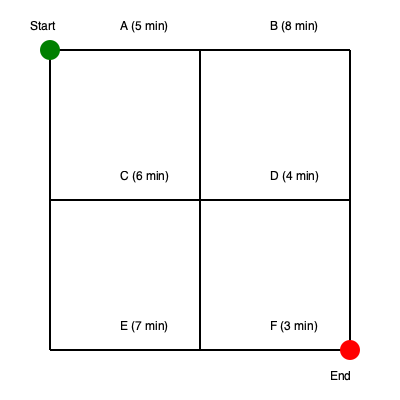As a firefighter coordinating an evacuation, you need to determine the fastest route from the start point (green) to the end point (red) through this grid-like road network. Each segment is labeled with its travel time in minutes. What is the minimum time required to reach the end point? To find the fastest route, we need to consider all possible paths and calculate their total times:

1. Start → A → B → D → F → End
   Time: $5 + 8 + 4 + 3 = 20$ minutes

2. Start → A → C → D → F → End
   Time: $5 + 6 + 4 + 3 = 18$ minutes

3. Start → A → C → E → F → End
   Time: $5 + 6 + 7 + 3 = 21$ minutes

4. Start → C → D → F → End
   Time: $6 + 4 + 3 = 13$ minutes

5. Start → C → E → F → End
   Time: $6 + 7 + 3 = 16$ minutes

The fastest route is option 4: Start → C → D → F → End, which takes 13 minutes.
Answer: 13 minutes 